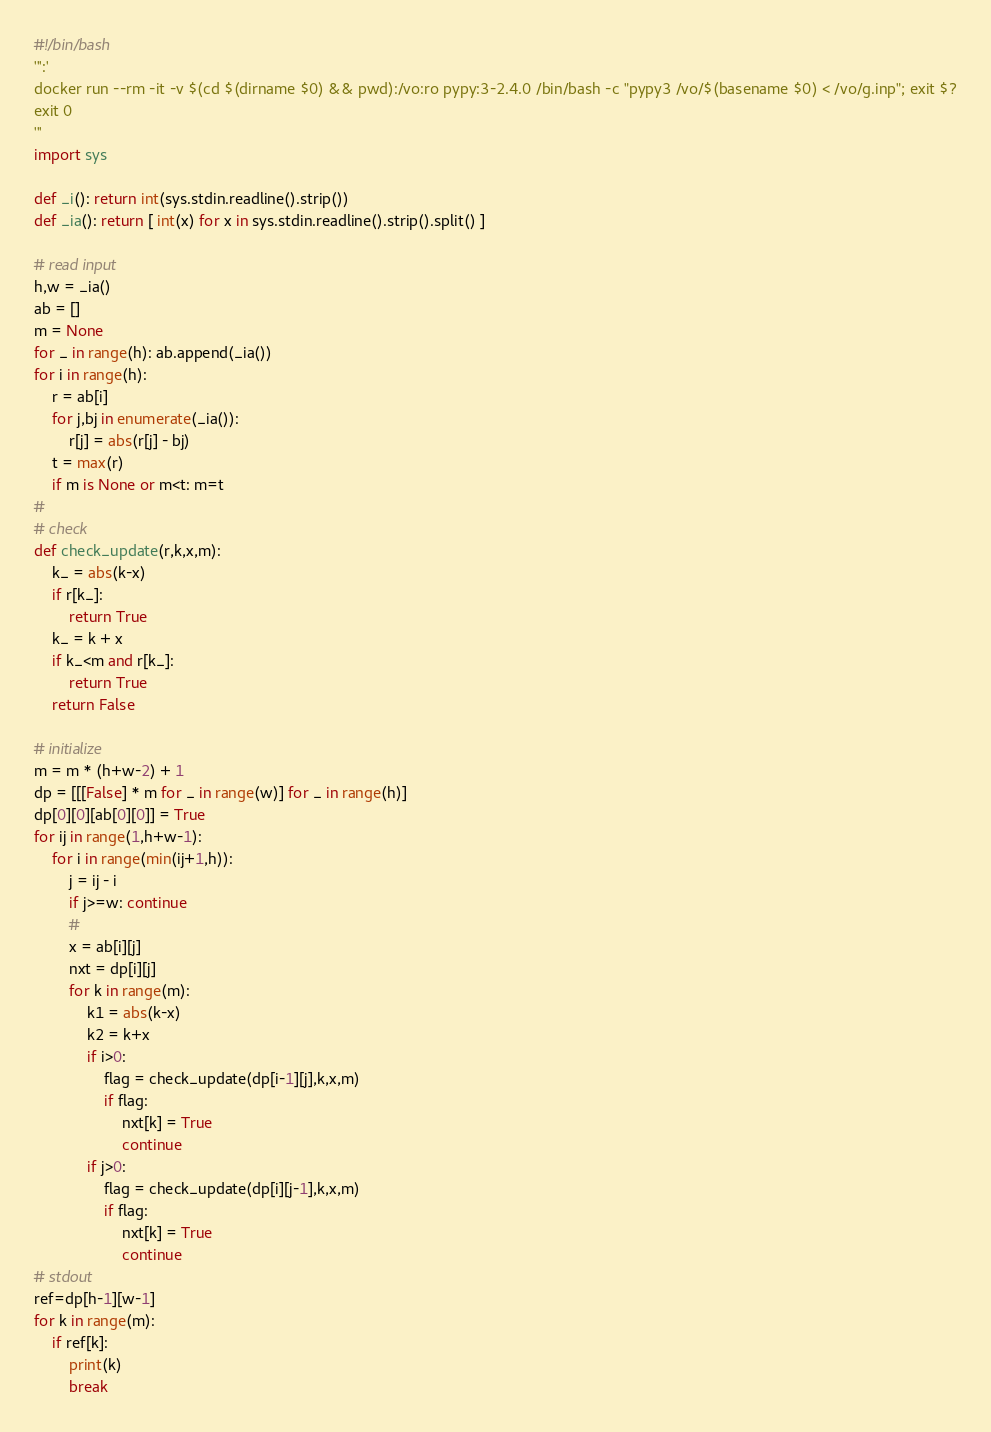<code> <loc_0><loc_0><loc_500><loc_500><_Python_>#!/bin/bash
''':'
docker run --rm -it -v $(cd $(dirname $0) && pwd):/vo:ro pypy:3-2.4.0 /bin/bash -c "pypy3 /vo/$(basename $0) < /vo/g.inp"; exit $?
exit 0
'''
import sys

def _i(): return int(sys.stdin.readline().strip())
def _ia(): return [ int(x) for x in sys.stdin.readline().strip().split() ]

# read input
h,w = _ia()
ab = []
m = None
for _ in range(h): ab.append(_ia())
for i in range(h):
    r = ab[i]
    for j,bj in enumerate(_ia()):
        r[j] = abs(r[j] - bj)
    t = max(r)
    if m is None or m<t: m=t
#
# check
def check_update(r,k,x,m):
    k_ = abs(k-x)
    if r[k_]:
        return True
    k_ = k + x
    if k_<m and r[k_]:
        return True
    return False
    
# initialize
m = m * (h+w-2) + 1
dp = [[[False] * m for _ in range(w)] for _ in range(h)]
dp[0][0][ab[0][0]] = True
for ij in range(1,h+w-1):
    for i in range(min(ij+1,h)):
        j = ij - i
        if j>=w: continue
        #
        x = ab[i][j]
        nxt = dp[i][j]
        for k in range(m):
            k1 = abs(k-x)
            k2 = k+x
            if i>0:
                flag = check_update(dp[i-1][j],k,x,m)
                if flag:
                    nxt[k] = True
                    continue
            if j>0:
                flag = check_update(dp[i][j-1],k,x,m)
                if flag:
                    nxt[k] = True
                    continue
# stdout
ref=dp[h-1][w-1]
for k in range(m):
    if ref[k]:
        print(k)
        break
</code> 